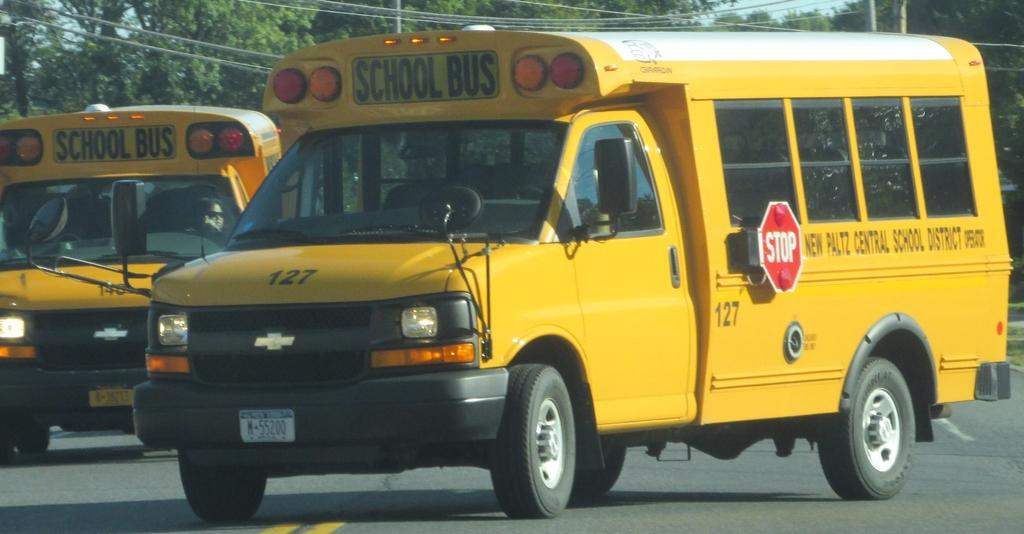<image>
Create a compact narrative representing the image presented. In a parking lot a scholol bus numbered 127 has its lights turned on. 